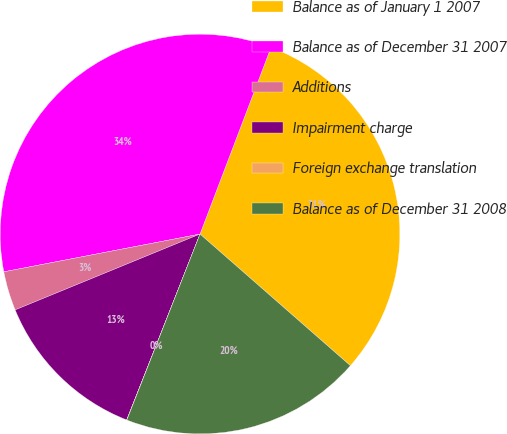Convert chart to OTSL. <chart><loc_0><loc_0><loc_500><loc_500><pie_chart><fcel>Balance as of January 1 2007<fcel>Balance as of December 31 2007<fcel>Additions<fcel>Impairment charge<fcel>Foreign exchange translation<fcel>Balance as of December 31 2008<nl><fcel>30.66%<fcel>33.81%<fcel>3.17%<fcel>12.82%<fcel>0.02%<fcel>19.52%<nl></chart> 